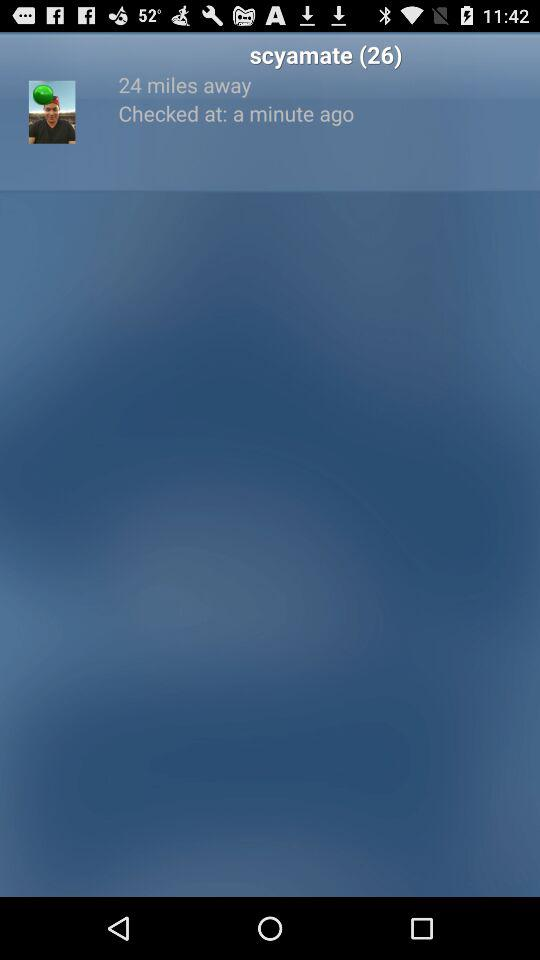At what time is the profile checked? The profile is checked a minute ago. 